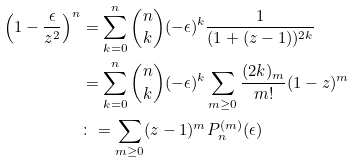<formula> <loc_0><loc_0><loc_500><loc_500>\left ( 1 - \frac { \epsilon } { z ^ { 2 } } \right ) ^ { n } & = \sum _ { k = 0 } ^ { n } \binom { n } { k } ( - \epsilon ) ^ { k } \frac { 1 } { ( 1 + ( z - 1 ) ) ^ { 2 k } } \\ & = \sum _ { k = 0 } ^ { n } \binom { n } { k } ( - \epsilon ) ^ { k } \sum _ { m \geq 0 } \frac { ( 2 k ) _ { m } } { m ! } ( 1 - z ) ^ { m } \\ & \colon = \sum _ { m \geq 0 } ( z - 1 ) ^ { m } P _ { n } ^ { ( m ) } ( \epsilon )</formula> 